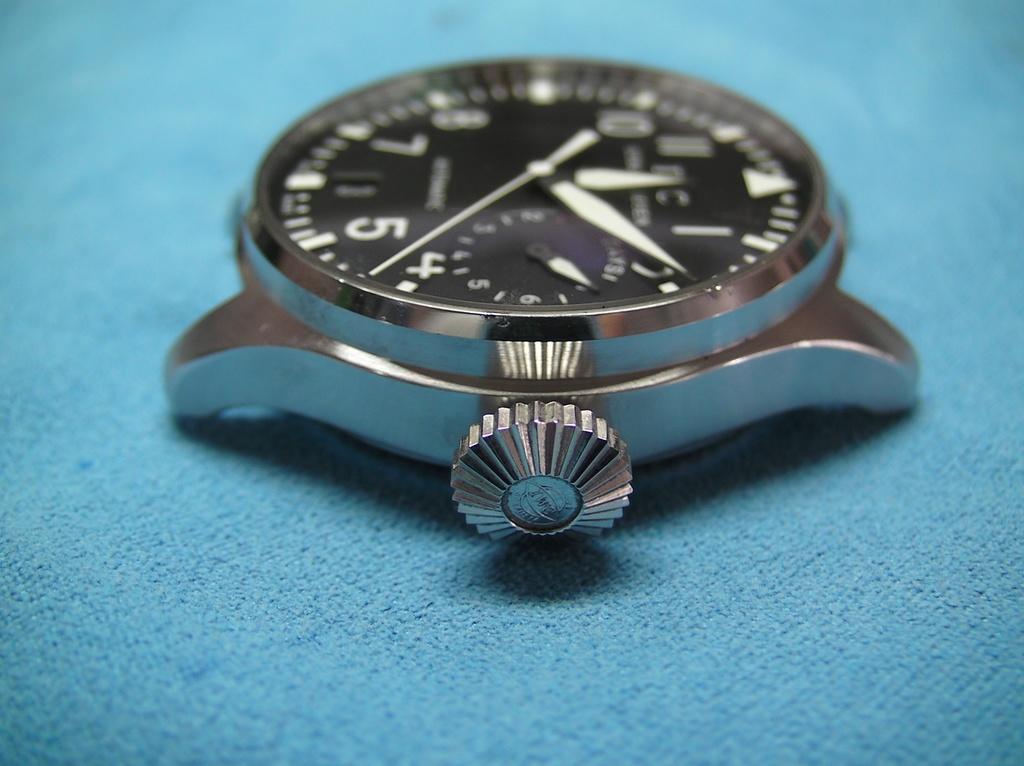What number does the second hand point closest to?
Provide a short and direct response. 2. 